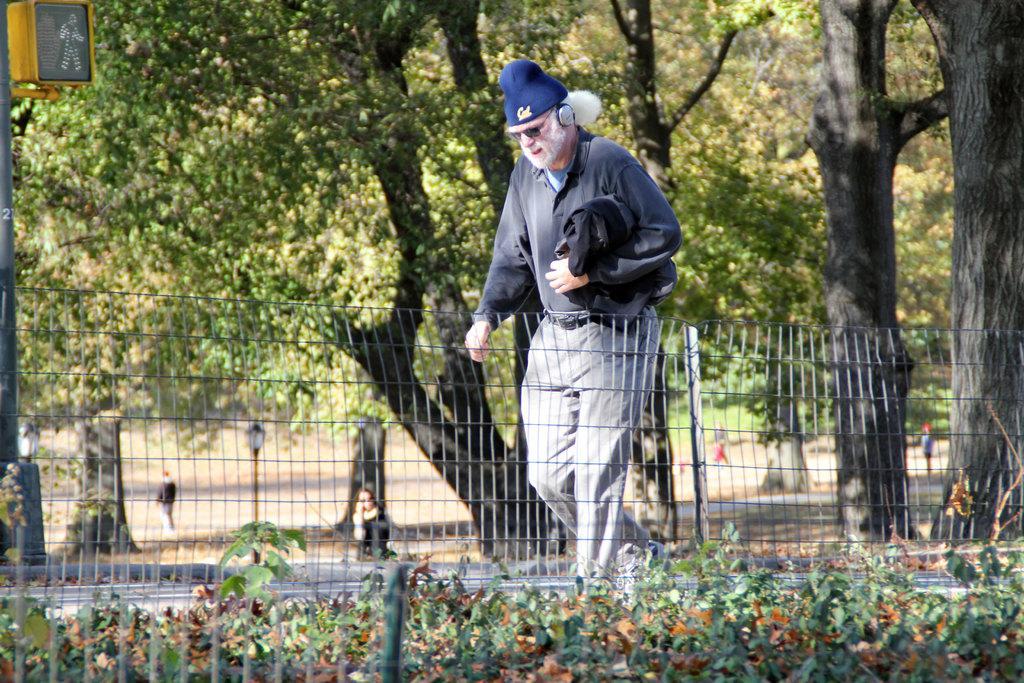Please provide a concise description of this image. In this image I can see the person walking on the road. He is wearing the grey color dress and there is a railing to the side. I can also see the pole to the left. In the background there are many trees and I can also see few more people on the ground. 